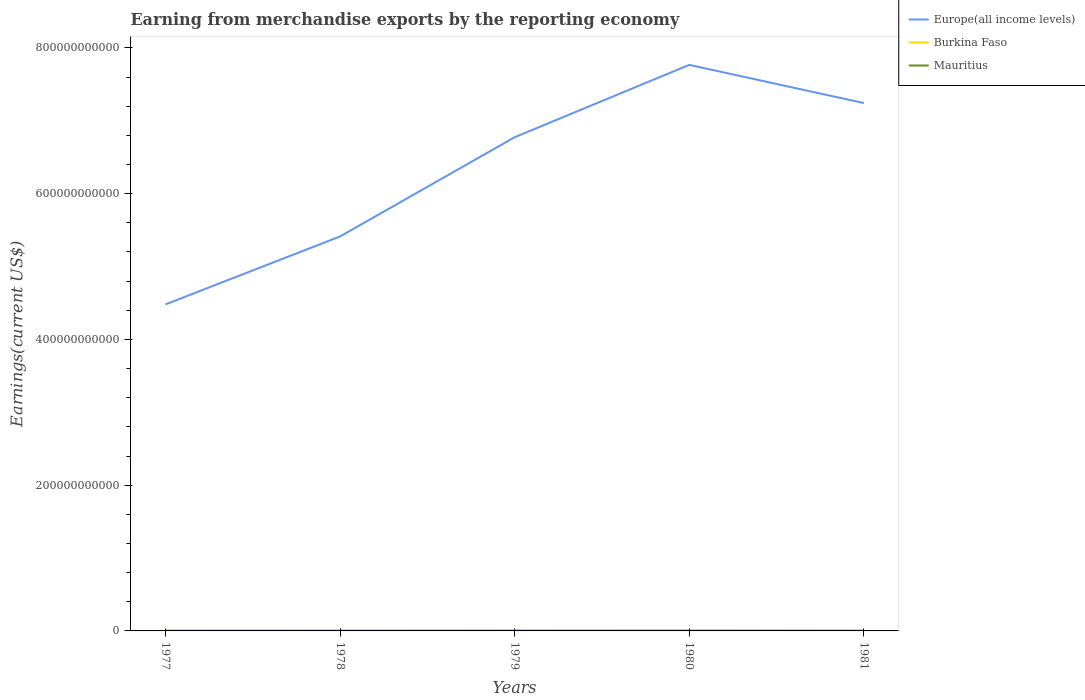How many different coloured lines are there?
Give a very brief answer. 3. Does the line corresponding to Europe(all income levels) intersect with the line corresponding to Burkina Faso?
Keep it short and to the point. No. Across all years, what is the maximum amount earned from merchandise exports in Europe(all income levels)?
Make the answer very short. 4.48e+11. What is the total amount earned from merchandise exports in Europe(all income levels) in the graph?
Your answer should be very brief. -9.93e+1. What is the difference between the highest and the second highest amount earned from merchandise exports in Europe(all income levels)?
Make the answer very short. 3.29e+11. Is the amount earned from merchandise exports in Mauritius strictly greater than the amount earned from merchandise exports in Burkina Faso over the years?
Your response must be concise. No. What is the difference between two consecutive major ticks on the Y-axis?
Give a very brief answer. 2.00e+11. Are the values on the major ticks of Y-axis written in scientific E-notation?
Your answer should be very brief. No. How many legend labels are there?
Ensure brevity in your answer.  3. How are the legend labels stacked?
Make the answer very short. Vertical. What is the title of the graph?
Ensure brevity in your answer.  Earning from merchandise exports by the reporting economy. What is the label or title of the Y-axis?
Make the answer very short. Earnings(current US$). What is the Earnings(current US$) of Europe(all income levels) in 1977?
Make the answer very short. 4.48e+11. What is the Earnings(current US$) in Burkina Faso in 1977?
Provide a succinct answer. 5.47e+07. What is the Earnings(current US$) of Mauritius in 1977?
Provide a short and direct response. 3.06e+08. What is the Earnings(current US$) of Europe(all income levels) in 1978?
Offer a very short reply. 5.41e+11. What is the Earnings(current US$) in Burkina Faso in 1978?
Provide a succinct answer. 4.21e+07. What is the Earnings(current US$) of Mauritius in 1978?
Give a very brief answer. 3.15e+08. What is the Earnings(current US$) of Europe(all income levels) in 1979?
Ensure brevity in your answer.  6.77e+11. What is the Earnings(current US$) of Burkina Faso in 1979?
Make the answer very short. 7.63e+07. What is the Earnings(current US$) in Mauritius in 1979?
Your answer should be very brief. 3.71e+08. What is the Earnings(current US$) of Europe(all income levels) in 1980?
Give a very brief answer. 7.77e+11. What is the Earnings(current US$) of Burkina Faso in 1980?
Keep it short and to the point. 9.02e+07. What is the Earnings(current US$) in Mauritius in 1980?
Your response must be concise. 4.29e+08. What is the Earnings(current US$) of Europe(all income levels) in 1981?
Offer a terse response. 7.24e+11. What is the Earnings(current US$) of Burkina Faso in 1981?
Offer a terse response. 7.33e+07. What is the Earnings(current US$) of Mauritius in 1981?
Offer a very short reply. 3.17e+08. Across all years, what is the maximum Earnings(current US$) of Europe(all income levels)?
Your response must be concise. 7.77e+11. Across all years, what is the maximum Earnings(current US$) of Burkina Faso?
Your answer should be very brief. 9.02e+07. Across all years, what is the maximum Earnings(current US$) of Mauritius?
Ensure brevity in your answer.  4.29e+08. Across all years, what is the minimum Earnings(current US$) of Europe(all income levels)?
Keep it short and to the point. 4.48e+11. Across all years, what is the minimum Earnings(current US$) in Burkina Faso?
Offer a very short reply. 4.21e+07. Across all years, what is the minimum Earnings(current US$) in Mauritius?
Your answer should be compact. 3.06e+08. What is the total Earnings(current US$) of Europe(all income levels) in the graph?
Provide a succinct answer. 3.17e+12. What is the total Earnings(current US$) of Burkina Faso in the graph?
Give a very brief answer. 3.37e+08. What is the total Earnings(current US$) in Mauritius in the graph?
Ensure brevity in your answer.  1.74e+09. What is the difference between the Earnings(current US$) in Europe(all income levels) in 1977 and that in 1978?
Your answer should be very brief. -9.32e+1. What is the difference between the Earnings(current US$) in Burkina Faso in 1977 and that in 1978?
Offer a terse response. 1.26e+07. What is the difference between the Earnings(current US$) of Mauritius in 1977 and that in 1978?
Make the answer very short. -8.21e+06. What is the difference between the Earnings(current US$) in Europe(all income levels) in 1977 and that in 1979?
Give a very brief answer. -2.29e+11. What is the difference between the Earnings(current US$) in Burkina Faso in 1977 and that in 1979?
Your response must be concise. -2.16e+07. What is the difference between the Earnings(current US$) of Mauritius in 1977 and that in 1979?
Provide a succinct answer. -6.48e+07. What is the difference between the Earnings(current US$) in Europe(all income levels) in 1977 and that in 1980?
Provide a succinct answer. -3.29e+11. What is the difference between the Earnings(current US$) in Burkina Faso in 1977 and that in 1980?
Your answer should be very brief. -3.55e+07. What is the difference between the Earnings(current US$) of Mauritius in 1977 and that in 1980?
Make the answer very short. -1.23e+08. What is the difference between the Earnings(current US$) in Europe(all income levels) in 1977 and that in 1981?
Offer a terse response. -2.76e+11. What is the difference between the Earnings(current US$) of Burkina Faso in 1977 and that in 1981?
Your answer should be compact. -1.86e+07. What is the difference between the Earnings(current US$) in Mauritius in 1977 and that in 1981?
Offer a terse response. -1.11e+07. What is the difference between the Earnings(current US$) of Europe(all income levels) in 1978 and that in 1979?
Your response must be concise. -1.36e+11. What is the difference between the Earnings(current US$) of Burkina Faso in 1978 and that in 1979?
Provide a succinct answer. -3.42e+07. What is the difference between the Earnings(current US$) in Mauritius in 1978 and that in 1979?
Your answer should be compact. -5.66e+07. What is the difference between the Earnings(current US$) in Europe(all income levels) in 1978 and that in 1980?
Make the answer very short. -2.35e+11. What is the difference between the Earnings(current US$) in Burkina Faso in 1978 and that in 1980?
Offer a terse response. -4.81e+07. What is the difference between the Earnings(current US$) in Mauritius in 1978 and that in 1980?
Ensure brevity in your answer.  -1.15e+08. What is the difference between the Earnings(current US$) of Europe(all income levels) in 1978 and that in 1981?
Give a very brief answer. -1.83e+11. What is the difference between the Earnings(current US$) of Burkina Faso in 1978 and that in 1981?
Provide a short and direct response. -3.12e+07. What is the difference between the Earnings(current US$) of Mauritius in 1978 and that in 1981?
Your response must be concise. -2.88e+06. What is the difference between the Earnings(current US$) of Europe(all income levels) in 1979 and that in 1980?
Make the answer very short. -9.93e+1. What is the difference between the Earnings(current US$) in Burkina Faso in 1979 and that in 1980?
Ensure brevity in your answer.  -1.39e+07. What is the difference between the Earnings(current US$) in Mauritius in 1979 and that in 1980?
Provide a short and direct response. -5.81e+07. What is the difference between the Earnings(current US$) of Europe(all income levels) in 1979 and that in 1981?
Your answer should be very brief. -4.69e+1. What is the difference between the Earnings(current US$) of Burkina Faso in 1979 and that in 1981?
Give a very brief answer. 3.03e+06. What is the difference between the Earnings(current US$) of Mauritius in 1979 and that in 1981?
Your response must be concise. 5.37e+07. What is the difference between the Earnings(current US$) of Europe(all income levels) in 1980 and that in 1981?
Ensure brevity in your answer.  5.24e+1. What is the difference between the Earnings(current US$) of Burkina Faso in 1980 and that in 1981?
Keep it short and to the point. 1.69e+07. What is the difference between the Earnings(current US$) of Mauritius in 1980 and that in 1981?
Ensure brevity in your answer.  1.12e+08. What is the difference between the Earnings(current US$) of Europe(all income levels) in 1977 and the Earnings(current US$) of Burkina Faso in 1978?
Provide a short and direct response. 4.48e+11. What is the difference between the Earnings(current US$) in Europe(all income levels) in 1977 and the Earnings(current US$) in Mauritius in 1978?
Your response must be concise. 4.48e+11. What is the difference between the Earnings(current US$) in Burkina Faso in 1977 and the Earnings(current US$) in Mauritius in 1978?
Keep it short and to the point. -2.60e+08. What is the difference between the Earnings(current US$) in Europe(all income levels) in 1977 and the Earnings(current US$) in Burkina Faso in 1979?
Offer a very short reply. 4.48e+11. What is the difference between the Earnings(current US$) in Europe(all income levels) in 1977 and the Earnings(current US$) in Mauritius in 1979?
Your answer should be very brief. 4.48e+11. What is the difference between the Earnings(current US$) of Burkina Faso in 1977 and the Earnings(current US$) of Mauritius in 1979?
Make the answer very short. -3.16e+08. What is the difference between the Earnings(current US$) in Europe(all income levels) in 1977 and the Earnings(current US$) in Burkina Faso in 1980?
Your answer should be very brief. 4.48e+11. What is the difference between the Earnings(current US$) of Europe(all income levels) in 1977 and the Earnings(current US$) of Mauritius in 1980?
Offer a terse response. 4.48e+11. What is the difference between the Earnings(current US$) in Burkina Faso in 1977 and the Earnings(current US$) in Mauritius in 1980?
Provide a short and direct response. -3.75e+08. What is the difference between the Earnings(current US$) of Europe(all income levels) in 1977 and the Earnings(current US$) of Burkina Faso in 1981?
Keep it short and to the point. 4.48e+11. What is the difference between the Earnings(current US$) in Europe(all income levels) in 1977 and the Earnings(current US$) in Mauritius in 1981?
Ensure brevity in your answer.  4.48e+11. What is the difference between the Earnings(current US$) in Burkina Faso in 1977 and the Earnings(current US$) in Mauritius in 1981?
Provide a succinct answer. -2.63e+08. What is the difference between the Earnings(current US$) in Europe(all income levels) in 1978 and the Earnings(current US$) in Burkina Faso in 1979?
Make the answer very short. 5.41e+11. What is the difference between the Earnings(current US$) in Europe(all income levels) in 1978 and the Earnings(current US$) in Mauritius in 1979?
Keep it short and to the point. 5.41e+11. What is the difference between the Earnings(current US$) in Burkina Faso in 1978 and the Earnings(current US$) in Mauritius in 1979?
Offer a very short reply. -3.29e+08. What is the difference between the Earnings(current US$) in Europe(all income levels) in 1978 and the Earnings(current US$) in Burkina Faso in 1980?
Provide a short and direct response. 5.41e+11. What is the difference between the Earnings(current US$) of Europe(all income levels) in 1978 and the Earnings(current US$) of Mauritius in 1980?
Your response must be concise. 5.41e+11. What is the difference between the Earnings(current US$) in Burkina Faso in 1978 and the Earnings(current US$) in Mauritius in 1980?
Keep it short and to the point. -3.87e+08. What is the difference between the Earnings(current US$) of Europe(all income levels) in 1978 and the Earnings(current US$) of Burkina Faso in 1981?
Offer a terse response. 5.41e+11. What is the difference between the Earnings(current US$) of Europe(all income levels) in 1978 and the Earnings(current US$) of Mauritius in 1981?
Keep it short and to the point. 5.41e+11. What is the difference between the Earnings(current US$) of Burkina Faso in 1978 and the Earnings(current US$) of Mauritius in 1981?
Ensure brevity in your answer.  -2.75e+08. What is the difference between the Earnings(current US$) of Europe(all income levels) in 1979 and the Earnings(current US$) of Burkina Faso in 1980?
Offer a very short reply. 6.77e+11. What is the difference between the Earnings(current US$) of Europe(all income levels) in 1979 and the Earnings(current US$) of Mauritius in 1980?
Provide a short and direct response. 6.77e+11. What is the difference between the Earnings(current US$) in Burkina Faso in 1979 and the Earnings(current US$) in Mauritius in 1980?
Keep it short and to the point. -3.53e+08. What is the difference between the Earnings(current US$) of Europe(all income levels) in 1979 and the Earnings(current US$) of Burkina Faso in 1981?
Your answer should be compact. 6.77e+11. What is the difference between the Earnings(current US$) of Europe(all income levels) in 1979 and the Earnings(current US$) of Mauritius in 1981?
Offer a terse response. 6.77e+11. What is the difference between the Earnings(current US$) of Burkina Faso in 1979 and the Earnings(current US$) of Mauritius in 1981?
Give a very brief answer. -2.41e+08. What is the difference between the Earnings(current US$) of Europe(all income levels) in 1980 and the Earnings(current US$) of Burkina Faso in 1981?
Offer a terse response. 7.77e+11. What is the difference between the Earnings(current US$) in Europe(all income levels) in 1980 and the Earnings(current US$) in Mauritius in 1981?
Your response must be concise. 7.76e+11. What is the difference between the Earnings(current US$) of Burkina Faso in 1980 and the Earnings(current US$) of Mauritius in 1981?
Offer a terse response. -2.27e+08. What is the average Earnings(current US$) of Europe(all income levels) per year?
Make the answer very short. 6.34e+11. What is the average Earnings(current US$) of Burkina Faso per year?
Provide a short and direct response. 6.73e+07. What is the average Earnings(current US$) in Mauritius per year?
Keep it short and to the point. 3.48e+08. In the year 1977, what is the difference between the Earnings(current US$) of Europe(all income levels) and Earnings(current US$) of Burkina Faso?
Keep it short and to the point. 4.48e+11. In the year 1977, what is the difference between the Earnings(current US$) of Europe(all income levels) and Earnings(current US$) of Mauritius?
Ensure brevity in your answer.  4.48e+11. In the year 1977, what is the difference between the Earnings(current US$) in Burkina Faso and Earnings(current US$) in Mauritius?
Your answer should be very brief. -2.52e+08. In the year 1978, what is the difference between the Earnings(current US$) in Europe(all income levels) and Earnings(current US$) in Burkina Faso?
Keep it short and to the point. 5.41e+11. In the year 1978, what is the difference between the Earnings(current US$) of Europe(all income levels) and Earnings(current US$) of Mauritius?
Provide a short and direct response. 5.41e+11. In the year 1978, what is the difference between the Earnings(current US$) of Burkina Faso and Earnings(current US$) of Mauritius?
Provide a succinct answer. -2.72e+08. In the year 1979, what is the difference between the Earnings(current US$) in Europe(all income levels) and Earnings(current US$) in Burkina Faso?
Keep it short and to the point. 6.77e+11. In the year 1979, what is the difference between the Earnings(current US$) of Europe(all income levels) and Earnings(current US$) of Mauritius?
Your answer should be compact. 6.77e+11. In the year 1979, what is the difference between the Earnings(current US$) of Burkina Faso and Earnings(current US$) of Mauritius?
Make the answer very short. -2.95e+08. In the year 1980, what is the difference between the Earnings(current US$) in Europe(all income levels) and Earnings(current US$) in Burkina Faso?
Make the answer very short. 7.77e+11. In the year 1980, what is the difference between the Earnings(current US$) in Europe(all income levels) and Earnings(current US$) in Mauritius?
Your response must be concise. 7.76e+11. In the year 1980, what is the difference between the Earnings(current US$) in Burkina Faso and Earnings(current US$) in Mauritius?
Make the answer very short. -3.39e+08. In the year 1981, what is the difference between the Earnings(current US$) of Europe(all income levels) and Earnings(current US$) of Burkina Faso?
Give a very brief answer. 7.24e+11. In the year 1981, what is the difference between the Earnings(current US$) of Europe(all income levels) and Earnings(current US$) of Mauritius?
Keep it short and to the point. 7.24e+11. In the year 1981, what is the difference between the Earnings(current US$) of Burkina Faso and Earnings(current US$) of Mauritius?
Make the answer very short. -2.44e+08. What is the ratio of the Earnings(current US$) in Europe(all income levels) in 1977 to that in 1978?
Offer a terse response. 0.83. What is the ratio of the Earnings(current US$) in Burkina Faso in 1977 to that in 1978?
Ensure brevity in your answer.  1.3. What is the ratio of the Earnings(current US$) in Mauritius in 1977 to that in 1978?
Offer a terse response. 0.97. What is the ratio of the Earnings(current US$) in Europe(all income levels) in 1977 to that in 1979?
Your answer should be compact. 0.66. What is the ratio of the Earnings(current US$) in Burkina Faso in 1977 to that in 1979?
Ensure brevity in your answer.  0.72. What is the ratio of the Earnings(current US$) of Mauritius in 1977 to that in 1979?
Ensure brevity in your answer.  0.83. What is the ratio of the Earnings(current US$) in Europe(all income levels) in 1977 to that in 1980?
Offer a terse response. 0.58. What is the ratio of the Earnings(current US$) of Burkina Faso in 1977 to that in 1980?
Keep it short and to the point. 0.61. What is the ratio of the Earnings(current US$) of Mauritius in 1977 to that in 1980?
Your answer should be very brief. 0.71. What is the ratio of the Earnings(current US$) of Europe(all income levels) in 1977 to that in 1981?
Your answer should be very brief. 0.62. What is the ratio of the Earnings(current US$) in Burkina Faso in 1977 to that in 1981?
Your answer should be very brief. 0.75. What is the ratio of the Earnings(current US$) of Mauritius in 1977 to that in 1981?
Keep it short and to the point. 0.97. What is the ratio of the Earnings(current US$) in Europe(all income levels) in 1978 to that in 1979?
Offer a terse response. 0.8. What is the ratio of the Earnings(current US$) in Burkina Faso in 1978 to that in 1979?
Your answer should be compact. 0.55. What is the ratio of the Earnings(current US$) in Mauritius in 1978 to that in 1979?
Offer a terse response. 0.85. What is the ratio of the Earnings(current US$) in Europe(all income levels) in 1978 to that in 1980?
Offer a terse response. 0.7. What is the ratio of the Earnings(current US$) in Burkina Faso in 1978 to that in 1980?
Ensure brevity in your answer.  0.47. What is the ratio of the Earnings(current US$) of Mauritius in 1978 to that in 1980?
Your answer should be compact. 0.73. What is the ratio of the Earnings(current US$) of Europe(all income levels) in 1978 to that in 1981?
Provide a short and direct response. 0.75. What is the ratio of the Earnings(current US$) of Burkina Faso in 1978 to that in 1981?
Ensure brevity in your answer.  0.57. What is the ratio of the Earnings(current US$) of Mauritius in 1978 to that in 1981?
Your answer should be very brief. 0.99. What is the ratio of the Earnings(current US$) of Europe(all income levels) in 1979 to that in 1980?
Keep it short and to the point. 0.87. What is the ratio of the Earnings(current US$) in Burkina Faso in 1979 to that in 1980?
Make the answer very short. 0.85. What is the ratio of the Earnings(current US$) in Mauritius in 1979 to that in 1980?
Offer a very short reply. 0.86. What is the ratio of the Earnings(current US$) in Europe(all income levels) in 1979 to that in 1981?
Keep it short and to the point. 0.94. What is the ratio of the Earnings(current US$) of Burkina Faso in 1979 to that in 1981?
Your answer should be compact. 1.04. What is the ratio of the Earnings(current US$) in Mauritius in 1979 to that in 1981?
Make the answer very short. 1.17. What is the ratio of the Earnings(current US$) in Europe(all income levels) in 1980 to that in 1981?
Your answer should be compact. 1.07. What is the ratio of the Earnings(current US$) in Burkina Faso in 1980 to that in 1981?
Offer a terse response. 1.23. What is the ratio of the Earnings(current US$) of Mauritius in 1980 to that in 1981?
Ensure brevity in your answer.  1.35. What is the difference between the highest and the second highest Earnings(current US$) of Europe(all income levels)?
Offer a terse response. 5.24e+1. What is the difference between the highest and the second highest Earnings(current US$) of Burkina Faso?
Your answer should be compact. 1.39e+07. What is the difference between the highest and the second highest Earnings(current US$) in Mauritius?
Your answer should be very brief. 5.81e+07. What is the difference between the highest and the lowest Earnings(current US$) of Europe(all income levels)?
Make the answer very short. 3.29e+11. What is the difference between the highest and the lowest Earnings(current US$) of Burkina Faso?
Your answer should be compact. 4.81e+07. What is the difference between the highest and the lowest Earnings(current US$) of Mauritius?
Offer a very short reply. 1.23e+08. 